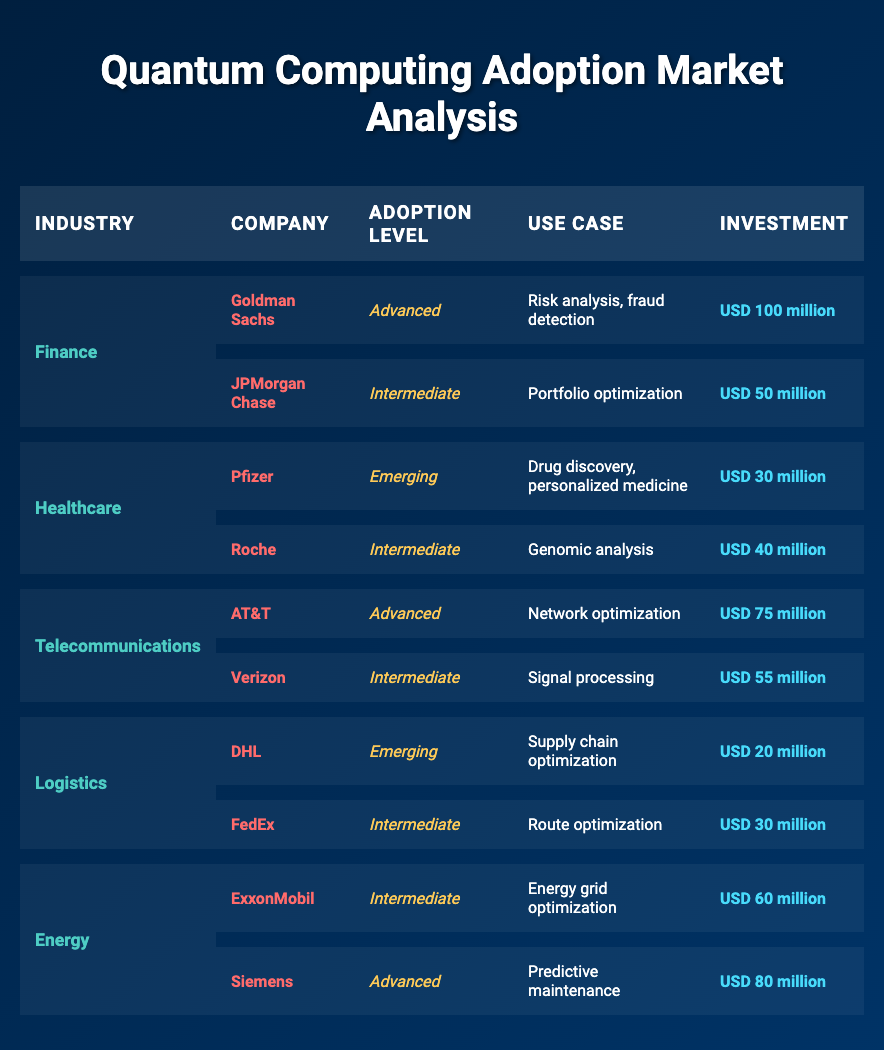What is the primary use case for Goldman Sachs in quantum computing? Referring to the table, Goldman Sachs has a use case listed as "Risk analysis, fraud detection." Thus, that is the primary application they are focusing on.
Answer: Risk analysis, fraud detection Which company has invested the most in quantum computing within the energy industry? In the energy industry, Siemens has an investment of USD 80 million, which is the highest among the listed companies in that sector.
Answer: Siemens True or False: Pfizer is at an advanced level of quantum computing adoption. According to the table, Pfizer is listed with an adoption level of "Emerging," therefore the statement is false.
Answer: False What is the total investment made by companies in the telecommunications industry? First, we sum the investments: AT&T has USD 75 million and Verizon has USD 55 million. Adding these gives USD 130 million as the total investment in this industry.
Answer: USD 130 million Which industry has the highest number of companies at an advanced level of adoption? By examining the table, we see that the finance and telecommunications industries each have one company (Goldman Sachs and AT&T, respectively) at an advanced level. However, the energy industry also has Siemens listed at an advanced level. Thus, all three of these industries have the same number of companies at that level: one each.
Answer: Finance, Telecommunications, Energy How many companies are included in the healthcare sector's adoption data? For healthcare, the table shows two companies: Pfizer and Roche. Counting them gives a total of 2 companies in this sector.
Answer: 2 What is the average investment made by companies in the logistics sector? In the logistics sector, DHL invested USD 20 million and FedEx invested USD 30 million. The average investment is calculated as (20 + 30) / 2 = 25 million.
Answer: USD 25 million Is there any company listed in the logistics industry at an advanced level of adoption? The table shows two companies in the logistics sector: DHL and FedEx. Both companies are listed as either "Emerging" or "Intermediate" in adoption levels. Therefore, there is no company at an advanced level.
Answer: No Based on the table, which company has the lowest investment in quantum computing and what is that amount? The lowest investment is found in the logistics sector, with DHL investing USD 20 million, which is less than any other shown investment in the table.
Answer: USD 20 million 